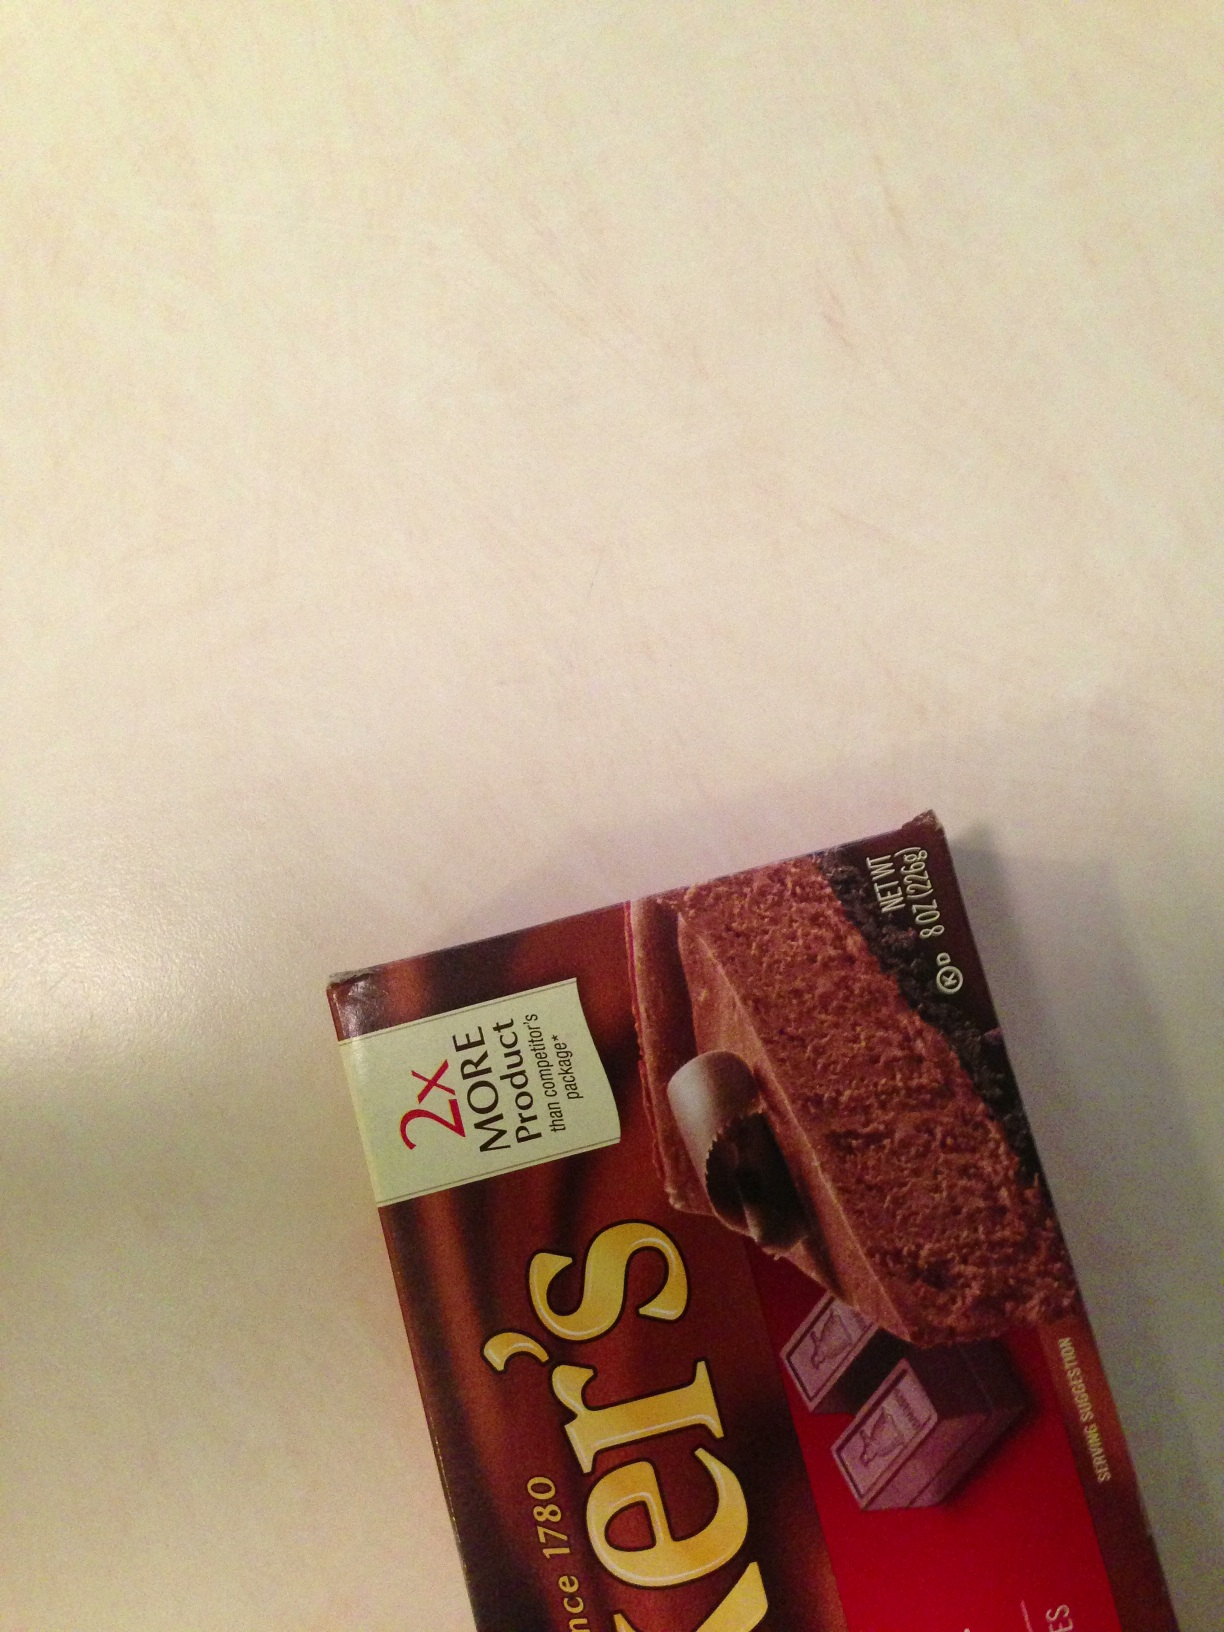Is this unsweetened or sweetened chocolate? This is unsweetened chocolate. The packaging shown in the image is of Baker's unsweetened chocolate, commonly used for baking purposes to provide a rich and intense chocolate flavor without any added sweetness. 